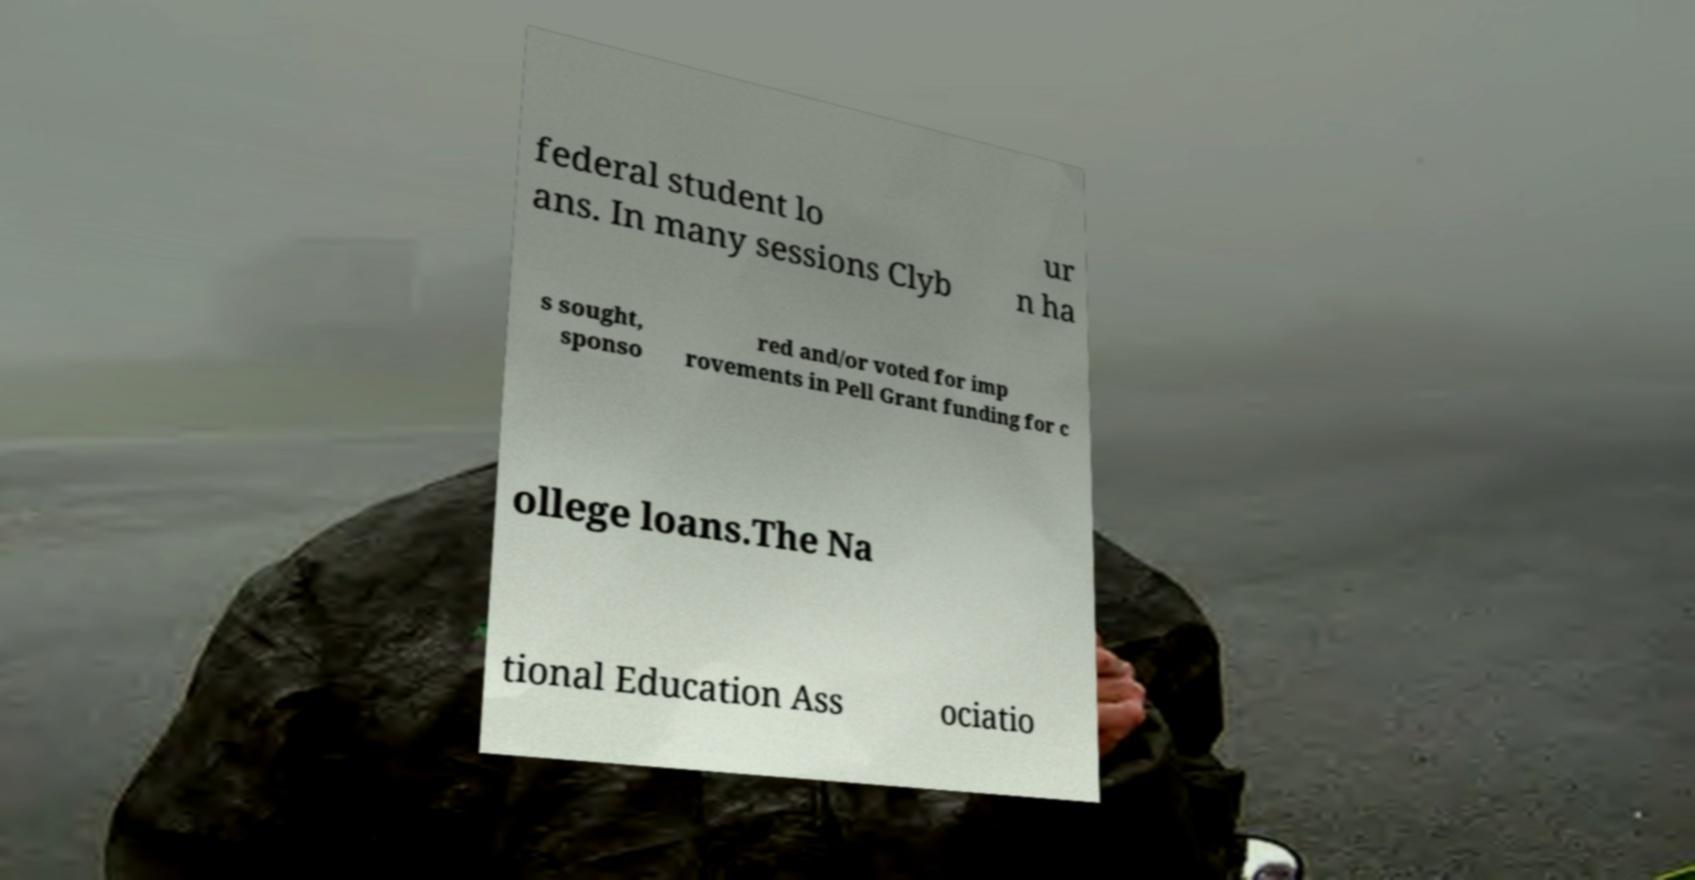Please read and relay the text visible in this image. What does it say? federal student lo ans. In many sessions Clyb ur n ha s sought, sponso red and/or voted for imp rovements in Pell Grant funding for c ollege loans.The Na tional Education Ass ociatio 